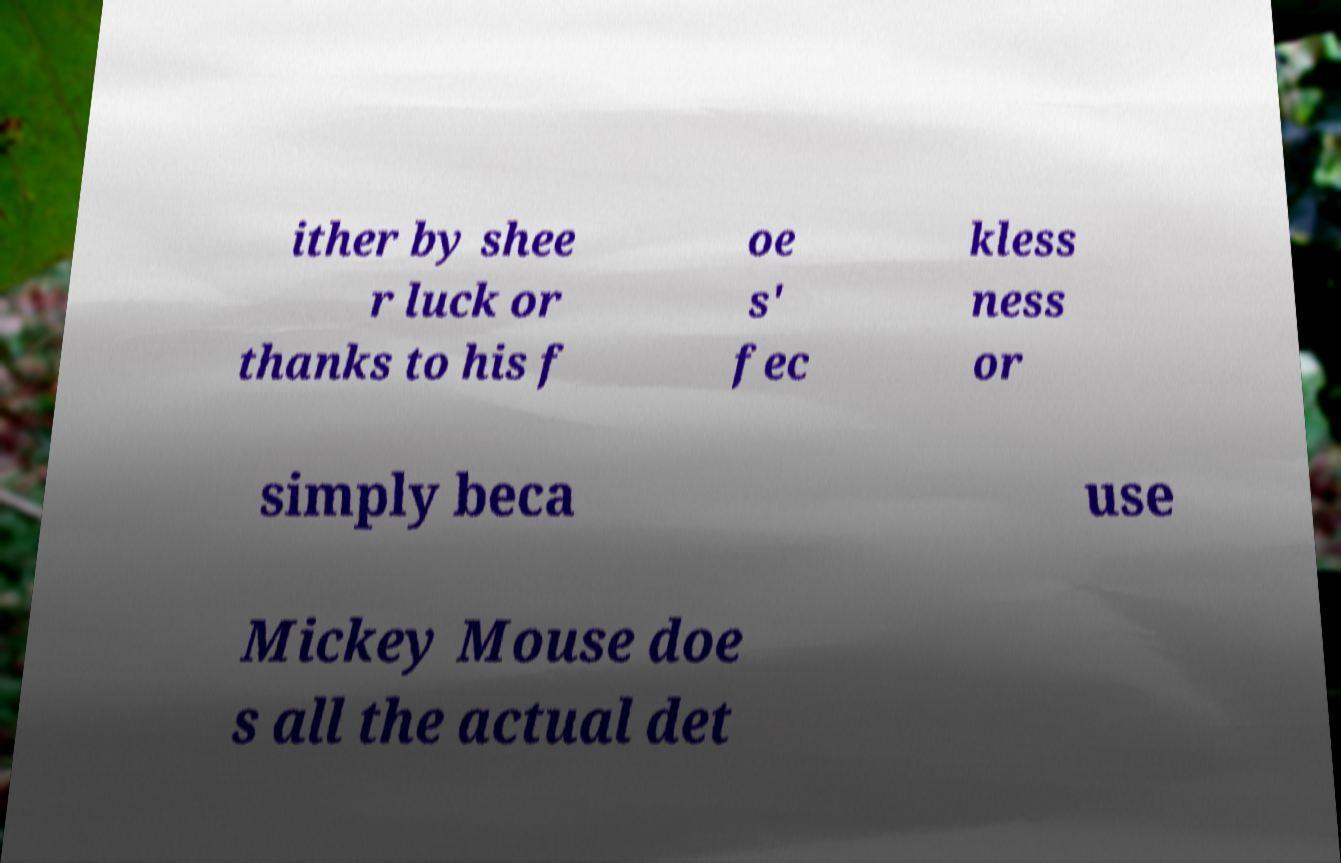Can you read and provide the text displayed in the image?This photo seems to have some interesting text. Can you extract and type it out for me? ither by shee r luck or thanks to his f oe s' fec kless ness or simply beca use Mickey Mouse doe s all the actual det 